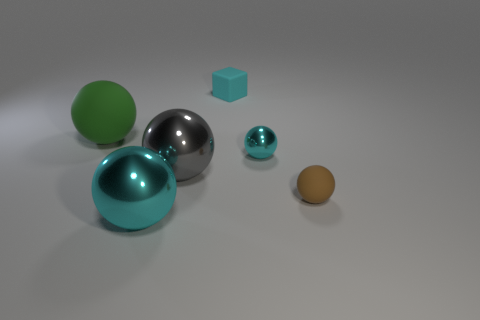There is a tiny rubber thing in front of the green sphere that is to the left of the small cube; what number of big metal spheres are in front of it?
Your response must be concise. 1. There is a large rubber ball; how many green spheres are behind it?
Keep it short and to the point. 0. The other small object that is the same shape as the small metal thing is what color?
Your response must be concise. Brown. The sphere that is behind the gray sphere and on the right side of the green sphere is made of what material?
Your answer should be very brief. Metal. There is a metal thing behind the gray sphere; does it have the same size as the green rubber thing?
Provide a short and direct response. No. What is the material of the brown thing?
Provide a short and direct response. Rubber. There is a tiny rubber thing in front of the rubber cube; what is its color?
Make the answer very short. Brown. What number of small objects are brown matte blocks or cyan matte objects?
Ensure brevity in your answer.  1. There is a matte sphere on the right side of the big green rubber ball; does it have the same color as the rubber ball that is behind the small brown rubber object?
Ensure brevity in your answer.  No. How many other things are the same color as the small shiny ball?
Give a very brief answer. 2. 